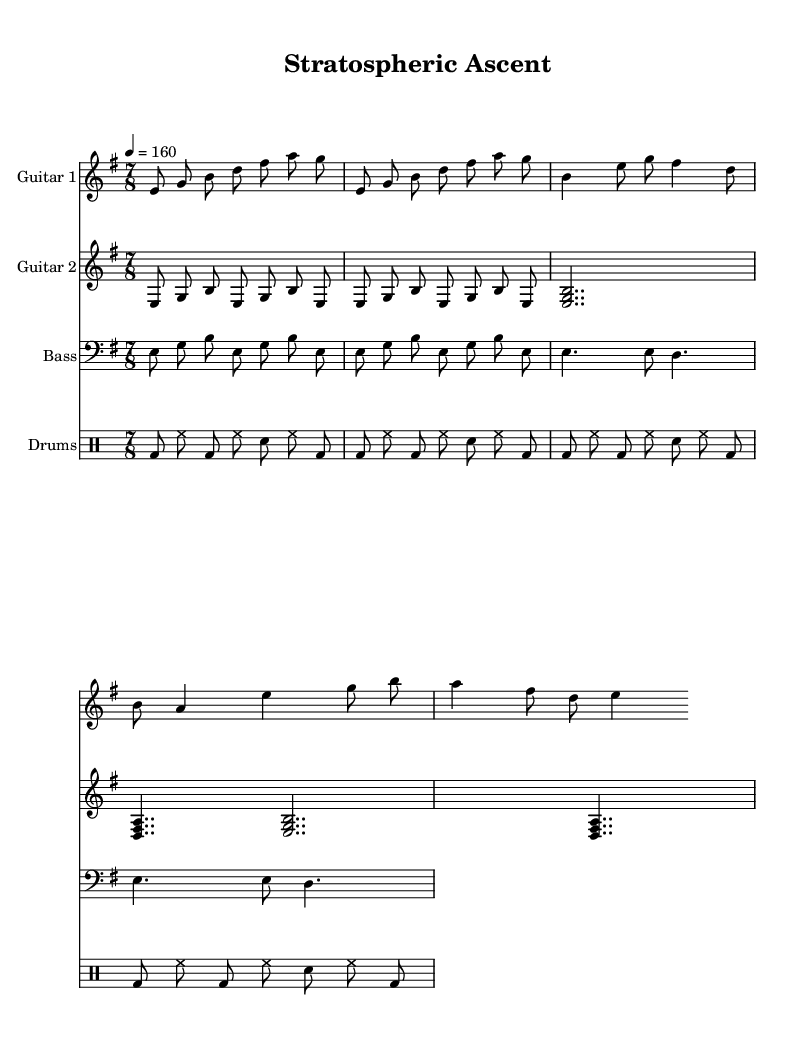What is the key signature of this music? The key signature shown in the music indicates there are two sharps, which corresponds to the key of B minor.
Answer: B minor What is the time signature of this composition? The time signature displayed in the music is 7/8, which means there are seven eighth-note beats in each measure.
Answer: 7/8 What is the tempo marking for this piece? The tempo marking shows "4 = 160", meaning there are 160 beats per minute when the quarter note gets the beat, indicating a fast-paced rhythm.
Answer: 160 Which instrument plays the simplified main riff? The second guitar part, marked as Guitar 2, plays the simplified main riff, which is indicated within its staff.
Answer: Guitar 2 How many measures are there in the chorus section of the composition? By analyzing the structure of the song, the chorus segment appears to repeat a set of measures with the melody and chords corresponding to the chorus, totaling 4 measures.
Answer: 4 In which section does the bass line transition from the main riff to the verse? The bass transitions from the main riff to the verse at the beginning of the verse section where it plays the rhythmic line indicated for that section.
Answer: The verse What type of rhythmic pattern is used in the drum part? The drum part uses a pattern featuring a combination of bass drums and hi-hat hits that create a driving, dynamic rhythm typical of metal music, characterized by multiple bass drum repeats.
Answer: Driving 